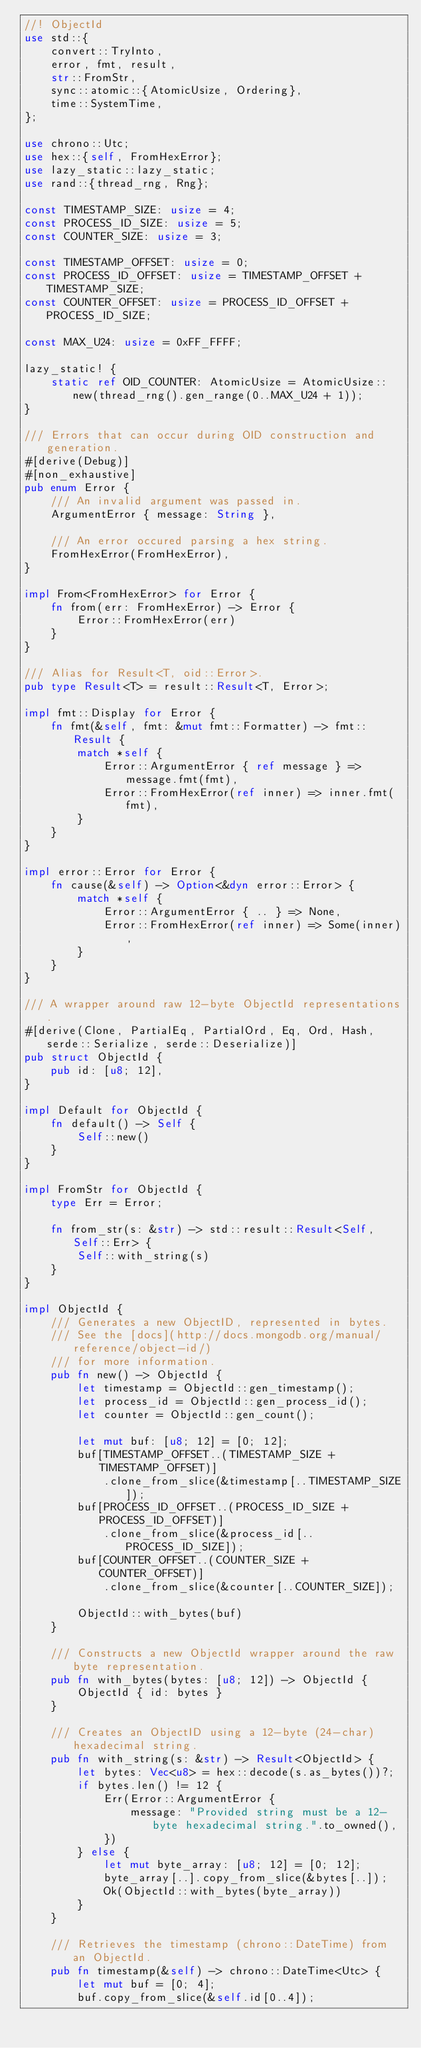<code> <loc_0><loc_0><loc_500><loc_500><_Rust_>//! ObjectId
use std::{
    convert::TryInto,
    error, fmt, result,
    str::FromStr,
    sync::atomic::{AtomicUsize, Ordering},
    time::SystemTime,
};

use chrono::Utc;
use hex::{self, FromHexError};
use lazy_static::lazy_static;
use rand::{thread_rng, Rng};

const TIMESTAMP_SIZE: usize = 4;
const PROCESS_ID_SIZE: usize = 5;
const COUNTER_SIZE: usize = 3;

const TIMESTAMP_OFFSET: usize = 0;
const PROCESS_ID_OFFSET: usize = TIMESTAMP_OFFSET + TIMESTAMP_SIZE;
const COUNTER_OFFSET: usize = PROCESS_ID_OFFSET + PROCESS_ID_SIZE;

const MAX_U24: usize = 0xFF_FFFF;

lazy_static! {
    static ref OID_COUNTER: AtomicUsize = AtomicUsize::new(thread_rng().gen_range(0..MAX_U24 + 1));
}

/// Errors that can occur during OID construction and generation.
#[derive(Debug)]
#[non_exhaustive]
pub enum Error {
    /// An invalid argument was passed in.
    ArgumentError { message: String },

    /// An error occured parsing a hex string.
    FromHexError(FromHexError),
}

impl From<FromHexError> for Error {
    fn from(err: FromHexError) -> Error {
        Error::FromHexError(err)
    }
}

/// Alias for Result<T, oid::Error>.
pub type Result<T> = result::Result<T, Error>;

impl fmt::Display for Error {
    fn fmt(&self, fmt: &mut fmt::Formatter) -> fmt::Result {
        match *self {
            Error::ArgumentError { ref message } => message.fmt(fmt),
            Error::FromHexError(ref inner) => inner.fmt(fmt),
        }
    }
}

impl error::Error for Error {
    fn cause(&self) -> Option<&dyn error::Error> {
        match *self {
            Error::ArgumentError { .. } => None,
            Error::FromHexError(ref inner) => Some(inner),
        }
    }
}

/// A wrapper around raw 12-byte ObjectId representations.
#[derive(Clone, PartialEq, PartialOrd, Eq, Ord, Hash, serde::Serialize, serde::Deserialize)]
pub struct ObjectId {
    pub id: [u8; 12],
}

impl Default for ObjectId {
    fn default() -> Self {
        Self::new()
    }
}

impl FromStr for ObjectId {
    type Err = Error;

    fn from_str(s: &str) -> std::result::Result<Self, Self::Err> {
        Self::with_string(s)
    }
}

impl ObjectId {
    /// Generates a new ObjectID, represented in bytes.
    /// See the [docs](http://docs.mongodb.org/manual/reference/object-id/)
    /// for more information.
    pub fn new() -> ObjectId {
        let timestamp = ObjectId::gen_timestamp();
        let process_id = ObjectId::gen_process_id();
        let counter = ObjectId::gen_count();

        let mut buf: [u8; 12] = [0; 12];
        buf[TIMESTAMP_OFFSET..(TIMESTAMP_SIZE + TIMESTAMP_OFFSET)]
            .clone_from_slice(&timestamp[..TIMESTAMP_SIZE]);
        buf[PROCESS_ID_OFFSET..(PROCESS_ID_SIZE + PROCESS_ID_OFFSET)]
            .clone_from_slice(&process_id[..PROCESS_ID_SIZE]);
        buf[COUNTER_OFFSET..(COUNTER_SIZE + COUNTER_OFFSET)]
            .clone_from_slice(&counter[..COUNTER_SIZE]);

        ObjectId::with_bytes(buf)
    }

    /// Constructs a new ObjectId wrapper around the raw byte representation.
    pub fn with_bytes(bytes: [u8; 12]) -> ObjectId {
        ObjectId { id: bytes }
    }

    /// Creates an ObjectID using a 12-byte (24-char) hexadecimal string.
    pub fn with_string(s: &str) -> Result<ObjectId> {
        let bytes: Vec<u8> = hex::decode(s.as_bytes())?;
        if bytes.len() != 12 {
            Err(Error::ArgumentError {
                message: "Provided string must be a 12-byte hexadecimal string.".to_owned(),
            })
        } else {
            let mut byte_array: [u8; 12] = [0; 12];
            byte_array[..].copy_from_slice(&bytes[..]);
            Ok(ObjectId::with_bytes(byte_array))
        }
    }

    /// Retrieves the timestamp (chrono::DateTime) from an ObjectId.
    pub fn timestamp(&self) -> chrono::DateTime<Utc> {
        let mut buf = [0; 4];
        buf.copy_from_slice(&self.id[0..4]);</code> 